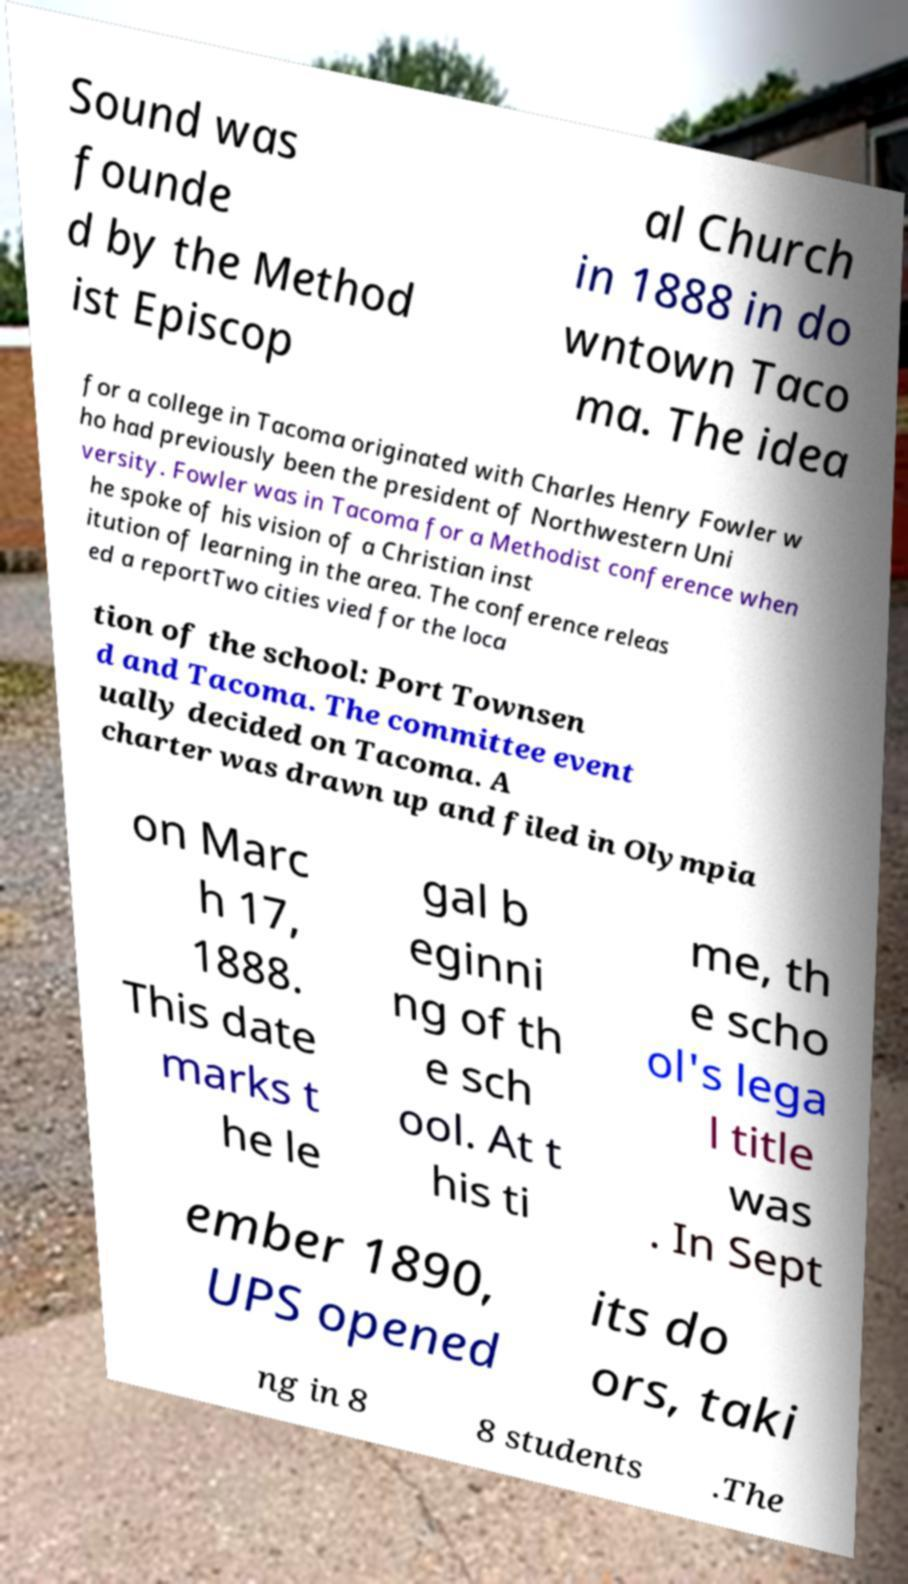Please identify and transcribe the text found in this image. Sound was founde d by the Method ist Episcop al Church in 1888 in do wntown Taco ma. The idea for a college in Tacoma originated with Charles Henry Fowler w ho had previously been the president of Northwestern Uni versity. Fowler was in Tacoma for a Methodist conference when he spoke of his vision of a Christian inst itution of learning in the area. The conference releas ed a reportTwo cities vied for the loca tion of the school: Port Townsen d and Tacoma. The committee event ually decided on Tacoma. A charter was drawn up and filed in Olympia on Marc h 17, 1888. This date marks t he le gal b eginni ng of th e sch ool. At t his ti me, th e scho ol's lega l title was . In Sept ember 1890, UPS opened its do ors, taki ng in 8 8 students .The 